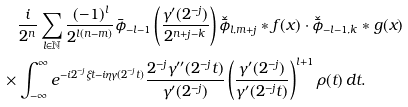<formula> <loc_0><loc_0><loc_500><loc_500>& \frac { i } { 2 ^ { n } } \sum _ { l \in \mathbb { N } } \frac { ( - 1 ) ^ { l } } { 2 ^ { l ( n - m ) } } \bar { \phi } _ { - l - 1 } \left ( \frac { \gamma ^ { \prime } ( 2 ^ { - j } ) } { 2 ^ { n + j - k } } \right ) \check { \bar { \phi } } _ { l , m + j } \ast f ( x ) \cdot \check { \bar { \phi } } _ { - l - 1 , k } \ast g ( x ) \\ \times & \int _ { - \infty } ^ { \infty } e ^ { - i 2 ^ { - j } \xi t - i \eta \gamma ( 2 ^ { - j } t ) } \frac { 2 ^ { - j } \gamma ^ { \prime \prime } ( 2 ^ { - j } t ) } { \gamma ^ { \prime } ( 2 ^ { - j } ) } \left ( \frac { \gamma ^ { \prime } ( 2 ^ { - j } ) } { \gamma ^ { \prime } ( 2 ^ { - j } t ) } \right ) ^ { l + 1 } \rho ( t ) \, d t .</formula> 